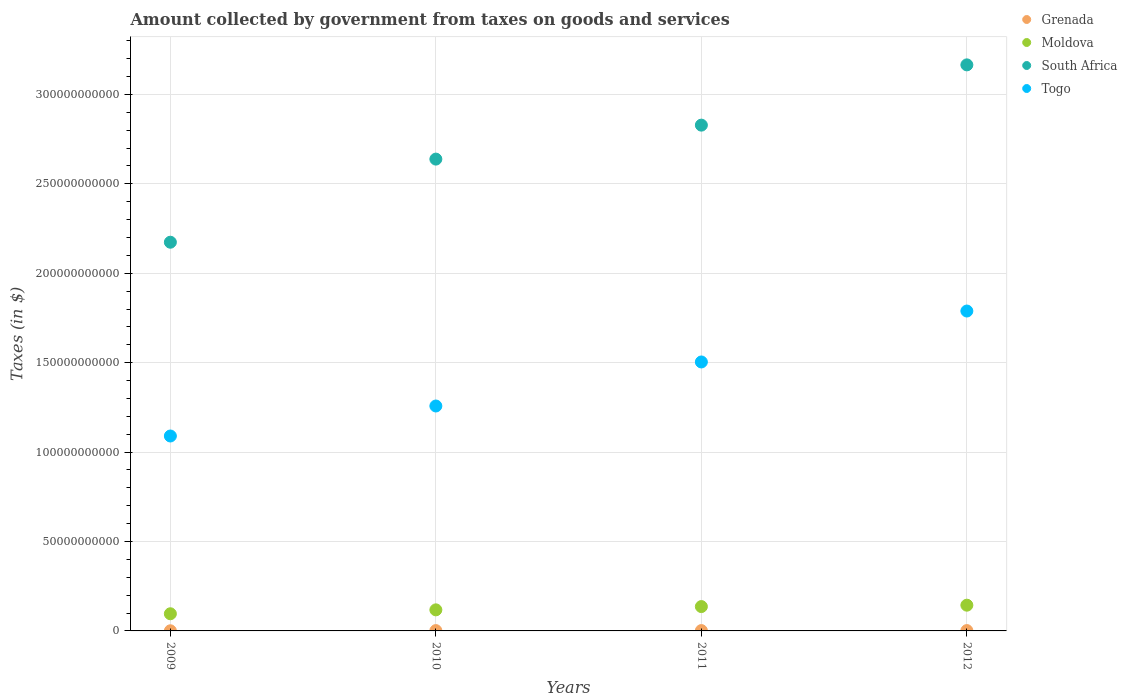What is the amount collected by government from taxes on goods and services in Grenada in 2009?
Provide a short and direct response. 7.60e+07. Across all years, what is the maximum amount collected by government from taxes on goods and services in South Africa?
Ensure brevity in your answer.  3.17e+11. Across all years, what is the minimum amount collected by government from taxes on goods and services in Moldova?
Give a very brief answer. 9.60e+09. In which year was the amount collected by government from taxes on goods and services in Grenada minimum?
Offer a very short reply. 2009. What is the total amount collected by government from taxes on goods and services in Togo in the graph?
Make the answer very short. 5.64e+11. What is the difference between the amount collected by government from taxes on goods and services in Togo in 2010 and that in 2011?
Your response must be concise. -2.46e+1. What is the difference between the amount collected by government from taxes on goods and services in Grenada in 2011 and the amount collected by government from taxes on goods and services in Moldova in 2009?
Keep it short and to the point. -9.41e+09. What is the average amount collected by government from taxes on goods and services in Moldova per year?
Your response must be concise. 1.23e+1. In the year 2009, what is the difference between the amount collected by government from taxes on goods and services in South Africa and amount collected by government from taxes on goods and services in Grenada?
Provide a succinct answer. 2.17e+11. In how many years, is the amount collected by government from taxes on goods and services in Togo greater than 210000000000 $?
Give a very brief answer. 0. What is the ratio of the amount collected by government from taxes on goods and services in Togo in 2011 to that in 2012?
Ensure brevity in your answer.  0.84. What is the difference between the highest and the second highest amount collected by government from taxes on goods and services in Togo?
Offer a terse response. 2.85e+1. What is the difference between the highest and the lowest amount collected by government from taxes on goods and services in Grenada?
Offer a terse response. 1.14e+08. Is it the case that in every year, the sum of the amount collected by government from taxes on goods and services in South Africa and amount collected by government from taxes on goods and services in Moldova  is greater than the sum of amount collected by government from taxes on goods and services in Togo and amount collected by government from taxes on goods and services in Grenada?
Offer a very short reply. Yes. How many dotlines are there?
Keep it short and to the point. 4. How many years are there in the graph?
Offer a terse response. 4. Does the graph contain any zero values?
Your response must be concise. No. How are the legend labels stacked?
Your answer should be very brief. Vertical. What is the title of the graph?
Offer a terse response. Amount collected by government from taxes on goods and services. What is the label or title of the Y-axis?
Keep it short and to the point. Taxes (in $). What is the Taxes (in $) in Grenada in 2009?
Your answer should be compact. 7.60e+07. What is the Taxes (in $) of Moldova in 2009?
Give a very brief answer. 9.60e+09. What is the Taxes (in $) of South Africa in 2009?
Provide a succinct answer. 2.17e+11. What is the Taxes (in $) in Togo in 2009?
Ensure brevity in your answer.  1.09e+11. What is the Taxes (in $) of Grenada in 2010?
Offer a very short reply. 1.78e+08. What is the Taxes (in $) in Moldova in 2010?
Give a very brief answer. 1.18e+1. What is the Taxes (in $) in South Africa in 2010?
Provide a succinct answer. 2.64e+11. What is the Taxes (in $) of Togo in 2010?
Make the answer very short. 1.26e+11. What is the Taxes (in $) in Grenada in 2011?
Keep it short and to the point. 1.90e+08. What is the Taxes (in $) in Moldova in 2011?
Your response must be concise. 1.36e+1. What is the Taxes (in $) of South Africa in 2011?
Ensure brevity in your answer.  2.83e+11. What is the Taxes (in $) in Togo in 2011?
Offer a very short reply. 1.50e+11. What is the Taxes (in $) of Grenada in 2012?
Offer a very short reply. 1.90e+08. What is the Taxes (in $) of Moldova in 2012?
Your answer should be very brief. 1.44e+1. What is the Taxes (in $) of South Africa in 2012?
Your response must be concise. 3.17e+11. What is the Taxes (in $) in Togo in 2012?
Make the answer very short. 1.79e+11. Across all years, what is the maximum Taxes (in $) of Grenada?
Offer a terse response. 1.90e+08. Across all years, what is the maximum Taxes (in $) of Moldova?
Ensure brevity in your answer.  1.44e+1. Across all years, what is the maximum Taxes (in $) in South Africa?
Your answer should be compact. 3.17e+11. Across all years, what is the maximum Taxes (in $) of Togo?
Your answer should be very brief. 1.79e+11. Across all years, what is the minimum Taxes (in $) in Grenada?
Offer a terse response. 7.60e+07. Across all years, what is the minimum Taxes (in $) of Moldova?
Keep it short and to the point. 9.60e+09. Across all years, what is the minimum Taxes (in $) of South Africa?
Provide a succinct answer. 2.17e+11. Across all years, what is the minimum Taxes (in $) of Togo?
Keep it short and to the point. 1.09e+11. What is the total Taxes (in $) of Grenada in the graph?
Make the answer very short. 6.34e+08. What is the total Taxes (in $) in Moldova in the graph?
Keep it short and to the point. 4.94e+1. What is the total Taxes (in $) of South Africa in the graph?
Give a very brief answer. 1.08e+12. What is the total Taxes (in $) of Togo in the graph?
Make the answer very short. 5.64e+11. What is the difference between the Taxes (in $) in Grenada in 2009 and that in 2010?
Ensure brevity in your answer.  -1.02e+08. What is the difference between the Taxes (in $) of Moldova in 2009 and that in 2010?
Your answer should be very brief. -2.19e+09. What is the difference between the Taxes (in $) in South Africa in 2009 and that in 2010?
Your answer should be compact. -4.65e+1. What is the difference between the Taxes (in $) of Togo in 2009 and that in 2010?
Ensure brevity in your answer.  -1.68e+1. What is the difference between the Taxes (in $) in Grenada in 2009 and that in 2011?
Your answer should be compact. -1.14e+08. What is the difference between the Taxes (in $) of Moldova in 2009 and that in 2011?
Give a very brief answer. -4.02e+09. What is the difference between the Taxes (in $) in South Africa in 2009 and that in 2011?
Provide a short and direct response. -6.55e+1. What is the difference between the Taxes (in $) in Togo in 2009 and that in 2011?
Offer a very short reply. -4.14e+1. What is the difference between the Taxes (in $) in Grenada in 2009 and that in 2012?
Keep it short and to the point. -1.14e+08. What is the difference between the Taxes (in $) of Moldova in 2009 and that in 2012?
Your answer should be compact. -4.80e+09. What is the difference between the Taxes (in $) of South Africa in 2009 and that in 2012?
Your response must be concise. -9.92e+1. What is the difference between the Taxes (in $) of Togo in 2009 and that in 2012?
Offer a terse response. -6.99e+1. What is the difference between the Taxes (in $) in Grenada in 2010 and that in 2011?
Your response must be concise. -1.16e+07. What is the difference between the Taxes (in $) of Moldova in 2010 and that in 2011?
Ensure brevity in your answer.  -1.83e+09. What is the difference between the Taxes (in $) of South Africa in 2010 and that in 2011?
Ensure brevity in your answer.  -1.90e+1. What is the difference between the Taxes (in $) of Togo in 2010 and that in 2011?
Provide a short and direct response. -2.46e+1. What is the difference between the Taxes (in $) in Grenada in 2010 and that in 2012?
Your response must be concise. -1.13e+07. What is the difference between the Taxes (in $) in Moldova in 2010 and that in 2012?
Your answer should be very brief. -2.61e+09. What is the difference between the Taxes (in $) in South Africa in 2010 and that in 2012?
Offer a very short reply. -5.27e+1. What is the difference between the Taxes (in $) in Togo in 2010 and that in 2012?
Ensure brevity in your answer.  -5.31e+1. What is the difference between the Taxes (in $) in Grenada in 2011 and that in 2012?
Make the answer very short. 3.00e+05. What is the difference between the Taxes (in $) in Moldova in 2011 and that in 2012?
Your answer should be very brief. -7.78e+08. What is the difference between the Taxes (in $) in South Africa in 2011 and that in 2012?
Your response must be concise. -3.37e+1. What is the difference between the Taxes (in $) in Togo in 2011 and that in 2012?
Provide a succinct answer. -2.85e+1. What is the difference between the Taxes (in $) in Grenada in 2009 and the Taxes (in $) in Moldova in 2010?
Offer a terse response. -1.17e+1. What is the difference between the Taxes (in $) of Grenada in 2009 and the Taxes (in $) of South Africa in 2010?
Provide a short and direct response. -2.64e+11. What is the difference between the Taxes (in $) of Grenada in 2009 and the Taxes (in $) of Togo in 2010?
Make the answer very short. -1.26e+11. What is the difference between the Taxes (in $) in Moldova in 2009 and the Taxes (in $) in South Africa in 2010?
Provide a short and direct response. -2.54e+11. What is the difference between the Taxes (in $) of Moldova in 2009 and the Taxes (in $) of Togo in 2010?
Offer a very short reply. -1.16e+11. What is the difference between the Taxes (in $) in South Africa in 2009 and the Taxes (in $) in Togo in 2010?
Offer a terse response. 9.16e+1. What is the difference between the Taxes (in $) of Grenada in 2009 and the Taxes (in $) of Moldova in 2011?
Provide a short and direct response. -1.35e+1. What is the difference between the Taxes (in $) in Grenada in 2009 and the Taxes (in $) in South Africa in 2011?
Your answer should be very brief. -2.83e+11. What is the difference between the Taxes (in $) in Grenada in 2009 and the Taxes (in $) in Togo in 2011?
Your answer should be compact. -1.50e+11. What is the difference between the Taxes (in $) of Moldova in 2009 and the Taxes (in $) of South Africa in 2011?
Provide a short and direct response. -2.73e+11. What is the difference between the Taxes (in $) of Moldova in 2009 and the Taxes (in $) of Togo in 2011?
Your response must be concise. -1.41e+11. What is the difference between the Taxes (in $) of South Africa in 2009 and the Taxes (in $) of Togo in 2011?
Your response must be concise. 6.70e+1. What is the difference between the Taxes (in $) in Grenada in 2009 and the Taxes (in $) in Moldova in 2012?
Your answer should be compact. -1.43e+1. What is the difference between the Taxes (in $) in Grenada in 2009 and the Taxes (in $) in South Africa in 2012?
Your answer should be very brief. -3.16e+11. What is the difference between the Taxes (in $) of Grenada in 2009 and the Taxes (in $) of Togo in 2012?
Keep it short and to the point. -1.79e+11. What is the difference between the Taxes (in $) in Moldova in 2009 and the Taxes (in $) in South Africa in 2012?
Your answer should be very brief. -3.07e+11. What is the difference between the Taxes (in $) in Moldova in 2009 and the Taxes (in $) in Togo in 2012?
Give a very brief answer. -1.69e+11. What is the difference between the Taxes (in $) in South Africa in 2009 and the Taxes (in $) in Togo in 2012?
Your response must be concise. 3.85e+1. What is the difference between the Taxes (in $) of Grenada in 2010 and the Taxes (in $) of Moldova in 2011?
Provide a succinct answer. -1.34e+1. What is the difference between the Taxes (in $) in Grenada in 2010 and the Taxes (in $) in South Africa in 2011?
Give a very brief answer. -2.83e+11. What is the difference between the Taxes (in $) in Grenada in 2010 and the Taxes (in $) in Togo in 2011?
Keep it short and to the point. -1.50e+11. What is the difference between the Taxes (in $) of Moldova in 2010 and the Taxes (in $) of South Africa in 2011?
Your answer should be compact. -2.71e+11. What is the difference between the Taxes (in $) of Moldova in 2010 and the Taxes (in $) of Togo in 2011?
Provide a succinct answer. -1.39e+11. What is the difference between the Taxes (in $) of South Africa in 2010 and the Taxes (in $) of Togo in 2011?
Offer a very short reply. 1.13e+11. What is the difference between the Taxes (in $) in Grenada in 2010 and the Taxes (in $) in Moldova in 2012?
Provide a succinct answer. -1.42e+1. What is the difference between the Taxes (in $) in Grenada in 2010 and the Taxes (in $) in South Africa in 2012?
Give a very brief answer. -3.16e+11. What is the difference between the Taxes (in $) of Grenada in 2010 and the Taxes (in $) of Togo in 2012?
Your response must be concise. -1.79e+11. What is the difference between the Taxes (in $) of Moldova in 2010 and the Taxes (in $) of South Africa in 2012?
Offer a very short reply. -3.05e+11. What is the difference between the Taxes (in $) in Moldova in 2010 and the Taxes (in $) in Togo in 2012?
Make the answer very short. -1.67e+11. What is the difference between the Taxes (in $) in South Africa in 2010 and the Taxes (in $) in Togo in 2012?
Your answer should be very brief. 8.50e+1. What is the difference between the Taxes (in $) of Grenada in 2011 and the Taxes (in $) of Moldova in 2012?
Make the answer very short. -1.42e+1. What is the difference between the Taxes (in $) of Grenada in 2011 and the Taxes (in $) of South Africa in 2012?
Provide a short and direct response. -3.16e+11. What is the difference between the Taxes (in $) in Grenada in 2011 and the Taxes (in $) in Togo in 2012?
Your response must be concise. -1.79e+11. What is the difference between the Taxes (in $) of Moldova in 2011 and the Taxes (in $) of South Africa in 2012?
Make the answer very short. -3.03e+11. What is the difference between the Taxes (in $) of Moldova in 2011 and the Taxes (in $) of Togo in 2012?
Give a very brief answer. -1.65e+11. What is the difference between the Taxes (in $) of South Africa in 2011 and the Taxes (in $) of Togo in 2012?
Ensure brevity in your answer.  1.04e+11. What is the average Taxes (in $) of Grenada per year?
Provide a short and direct response. 1.58e+08. What is the average Taxes (in $) of Moldova per year?
Provide a short and direct response. 1.23e+1. What is the average Taxes (in $) in South Africa per year?
Your answer should be compact. 2.70e+11. What is the average Taxes (in $) in Togo per year?
Provide a succinct answer. 1.41e+11. In the year 2009, what is the difference between the Taxes (in $) of Grenada and Taxes (in $) of Moldova?
Give a very brief answer. -9.52e+09. In the year 2009, what is the difference between the Taxes (in $) in Grenada and Taxes (in $) in South Africa?
Give a very brief answer. -2.17e+11. In the year 2009, what is the difference between the Taxes (in $) of Grenada and Taxes (in $) of Togo?
Your response must be concise. -1.09e+11. In the year 2009, what is the difference between the Taxes (in $) in Moldova and Taxes (in $) in South Africa?
Ensure brevity in your answer.  -2.08e+11. In the year 2009, what is the difference between the Taxes (in $) in Moldova and Taxes (in $) in Togo?
Provide a succinct answer. -9.94e+1. In the year 2009, what is the difference between the Taxes (in $) in South Africa and Taxes (in $) in Togo?
Provide a short and direct response. 1.08e+11. In the year 2010, what is the difference between the Taxes (in $) of Grenada and Taxes (in $) of Moldova?
Offer a very short reply. -1.16e+1. In the year 2010, what is the difference between the Taxes (in $) in Grenada and Taxes (in $) in South Africa?
Your answer should be very brief. -2.64e+11. In the year 2010, what is the difference between the Taxes (in $) of Grenada and Taxes (in $) of Togo?
Make the answer very short. -1.26e+11. In the year 2010, what is the difference between the Taxes (in $) of Moldova and Taxes (in $) of South Africa?
Your answer should be compact. -2.52e+11. In the year 2010, what is the difference between the Taxes (in $) of Moldova and Taxes (in $) of Togo?
Provide a short and direct response. -1.14e+11. In the year 2010, what is the difference between the Taxes (in $) in South Africa and Taxes (in $) in Togo?
Ensure brevity in your answer.  1.38e+11. In the year 2011, what is the difference between the Taxes (in $) in Grenada and Taxes (in $) in Moldova?
Make the answer very short. -1.34e+1. In the year 2011, what is the difference between the Taxes (in $) in Grenada and Taxes (in $) in South Africa?
Your answer should be compact. -2.83e+11. In the year 2011, what is the difference between the Taxes (in $) of Grenada and Taxes (in $) of Togo?
Provide a succinct answer. -1.50e+11. In the year 2011, what is the difference between the Taxes (in $) in Moldova and Taxes (in $) in South Africa?
Your answer should be very brief. -2.69e+11. In the year 2011, what is the difference between the Taxes (in $) of Moldova and Taxes (in $) of Togo?
Your answer should be very brief. -1.37e+11. In the year 2011, what is the difference between the Taxes (in $) in South Africa and Taxes (in $) in Togo?
Offer a very short reply. 1.32e+11. In the year 2012, what is the difference between the Taxes (in $) in Grenada and Taxes (in $) in Moldova?
Keep it short and to the point. -1.42e+1. In the year 2012, what is the difference between the Taxes (in $) of Grenada and Taxes (in $) of South Africa?
Keep it short and to the point. -3.16e+11. In the year 2012, what is the difference between the Taxes (in $) in Grenada and Taxes (in $) in Togo?
Make the answer very short. -1.79e+11. In the year 2012, what is the difference between the Taxes (in $) in Moldova and Taxes (in $) in South Africa?
Offer a very short reply. -3.02e+11. In the year 2012, what is the difference between the Taxes (in $) of Moldova and Taxes (in $) of Togo?
Offer a terse response. -1.64e+11. In the year 2012, what is the difference between the Taxes (in $) of South Africa and Taxes (in $) of Togo?
Keep it short and to the point. 1.38e+11. What is the ratio of the Taxes (in $) in Grenada in 2009 to that in 2010?
Your answer should be compact. 0.43. What is the ratio of the Taxes (in $) of Moldova in 2009 to that in 2010?
Offer a very short reply. 0.81. What is the ratio of the Taxes (in $) of South Africa in 2009 to that in 2010?
Offer a very short reply. 0.82. What is the ratio of the Taxes (in $) in Togo in 2009 to that in 2010?
Your response must be concise. 0.87. What is the ratio of the Taxes (in $) in Grenada in 2009 to that in 2011?
Offer a very short reply. 0.4. What is the ratio of the Taxes (in $) of Moldova in 2009 to that in 2011?
Provide a succinct answer. 0.7. What is the ratio of the Taxes (in $) in South Africa in 2009 to that in 2011?
Ensure brevity in your answer.  0.77. What is the ratio of the Taxes (in $) of Togo in 2009 to that in 2011?
Give a very brief answer. 0.72. What is the ratio of the Taxes (in $) of Grenada in 2009 to that in 2012?
Offer a terse response. 0.4. What is the ratio of the Taxes (in $) of Moldova in 2009 to that in 2012?
Your response must be concise. 0.67. What is the ratio of the Taxes (in $) in South Africa in 2009 to that in 2012?
Offer a terse response. 0.69. What is the ratio of the Taxes (in $) in Togo in 2009 to that in 2012?
Your response must be concise. 0.61. What is the ratio of the Taxes (in $) of Grenada in 2010 to that in 2011?
Your answer should be compact. 0.94. What is the ratio of the Taxes (in $) in Moldova in 2010 to that in 2011?
Make the answer very short. 0.87. What is the ratio of the Taxes (in $) of South Africa in 2010 to that in 2011?
Give a very brief answer. 0.93. What is the ratio of the Taxes (in $) in Togo in 2010 to that in 2011?
Provide a succinct answer. 0.84. What is the ratio of the Taxes (in $) in Grenada in 2010 to that in 2012?
Provide a succinct answer. 0.94. What is the ratio of the Taxes (in $) in Moldova in 2010 to that in 2012?
Offer a terse response. 0.82. What is the ratio of the Taxes (in $) of South Africa in 2010 to that in 2012?
Provide a succinct answer. 0.83. What is the ratio of the Taxes (in $) of Togo in 2010 to that in 2012?
Your answer should be very brief. 0.7. What is the ratio of the Taxes (in $) of Moldova in 2011 to that in 2012?
Offer a very short reply. 0.95. What is the ratio of the Taxes (in $) of South Africa in 2011 to that in 2012?
Give a very brief answer. 0.89. What is the ratio of the Taxes (in $) in Togo in 2011 to that in 2012?
Your answer should be very brief. 0.84. What is the difference between the highest and the second highest Taxes (in $) of Moldova?
Offer a terse response. 7.78e+08. What is the difference between the highest and the second highest Taxes (in $) of South Africa?
Your answer should be very brief. 3.37e+1. What is the difference between the highest and the second highest Taxes (in $) in Togo?
Provide a short and direct response. 2.85e+1. What is the difference between the highest and the lowest Taxes (in $) of Grenada?
Your answer should be compact. 1.14e+08. What is the difference between the highest and the lowest Taxes (in $) in Moldova?
Offer a terse response. 4.80e+09. What is the difference between the highest and the lowest Taxes (in $) in South Africa?
Provide a succinct answer. 9.92e+1. What is the difference between the highest and the lowest Taxes (in $) of Togo?
Offer a terse response. 6.99e+1. 